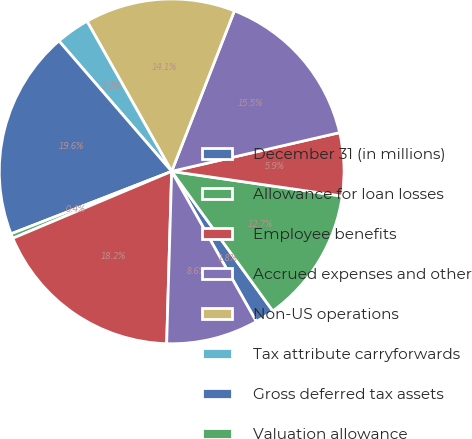Convert chart. <chart><loc_0><loc_0><loc_500><loc_500><pie_chart><fcel>December 31 (in millions)<fcel>Allowance for loan losses<fcel>Employee benefits<fcel>Accrued expenses and other<fcel>Non-US operations<fcel>Tax attribute carryforwards<fcel>Gross deferred tax assets<fcel>Valuation allowance<fcel>Deferred tax assets net of<fcel>Depreciation and amortization<nl><fcel>1.81%<fcel>12.73%<fcel>5.9%<fcel>15.46%<fcel>14.1%<fcel>3.17%<fcel>19.56%<fcel>0.44%<fcel>18.19%<fcel>8.63%<nl></chart> 